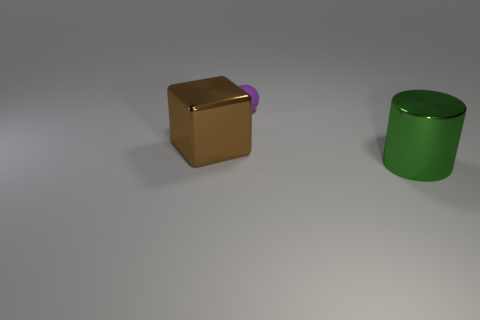Are there any rubber balls that are behind the big shiny object that is to the right of the sphere?
Make the answer very short. Yes. What shape is the large thing that is on the right side of the metal object that is to the left of the big metal object right of the purple sphere?
Offer a terse response. Cylinder. What is the color of the thing that is behind the green metallic cylinder and to the right of the block?
Your response must be concise. Purple. The large metallic object that is right of the tiny object has what shape?
Offer a very short reply. Cylinder. What is the shape of the big brown object that is the same material as the green cylinder?
Offer a terse response. Cube. What number of rubber objects are either large brown objects or small brown objects?
Keep it short and to the point. 0. How many balls are behind the metal object that is right of the large object left of the purple object?
Provide a short and direct response. 1. There is a brown object to the left of the large metallic cylinder; does it have the same size as the shiny thing that is right of the tiny thing?
Offer a very short reply. Yes. How many small things are purple matte spheres or red matte balls?
Your response must be concise. 1. What is the material of the purple ball?
Your response must be concise. Rubber. 